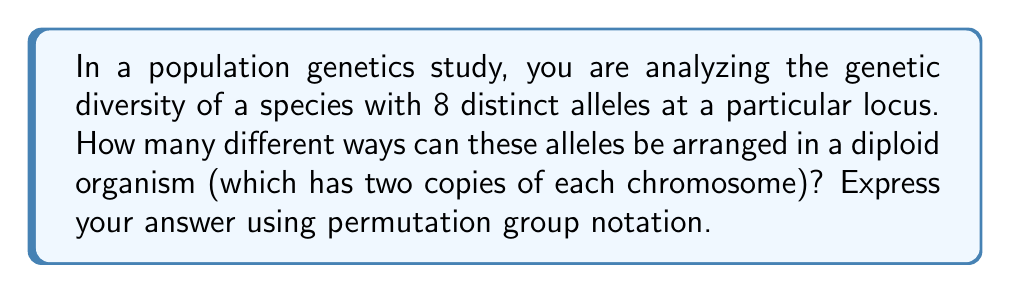Can you answer this question? To solve this problem, we need to consider the following steps:

1) In a diploid organism, we are arranging 8 alleles into 2 positions (one for each chromosome).

2) This scenario can be modeled as a permutation with repetition, where the order matters and elements can be repeated.

3) In permutation group theory, this is equivalent to the wreath product of $S_2$ (the symmetric group on 2 elements) and $S_8$ (the symmetric group on 8 elements), denoted as $S_2 \wr S_8$.

4) The order of this wreath product is given by the formula:

   $$|S_2 \wr S_8| = |S_2|^8 \cdot |S_8|$$

5) We know that:
   - $|S_2| = 2!$ (the number of ways to arrange 2 elements)
   - $|S_8| = 8!$ (the number of ways to arrange 8 elements)

6) Substituting these values:

   $$|S_2 \wr S_8| = (2!)^8 \cdot 8!$$

7) Simplifying:
   $$(2^8) \cdot (8!) = 256 \cdot 40,320 = 10,321,920$$

Therefore, there are 10,321,920 different ways to arrange the 8 alleles in a diploid organism.
Answer: $|S_2 \wr S_8| = 10,321,920$ 